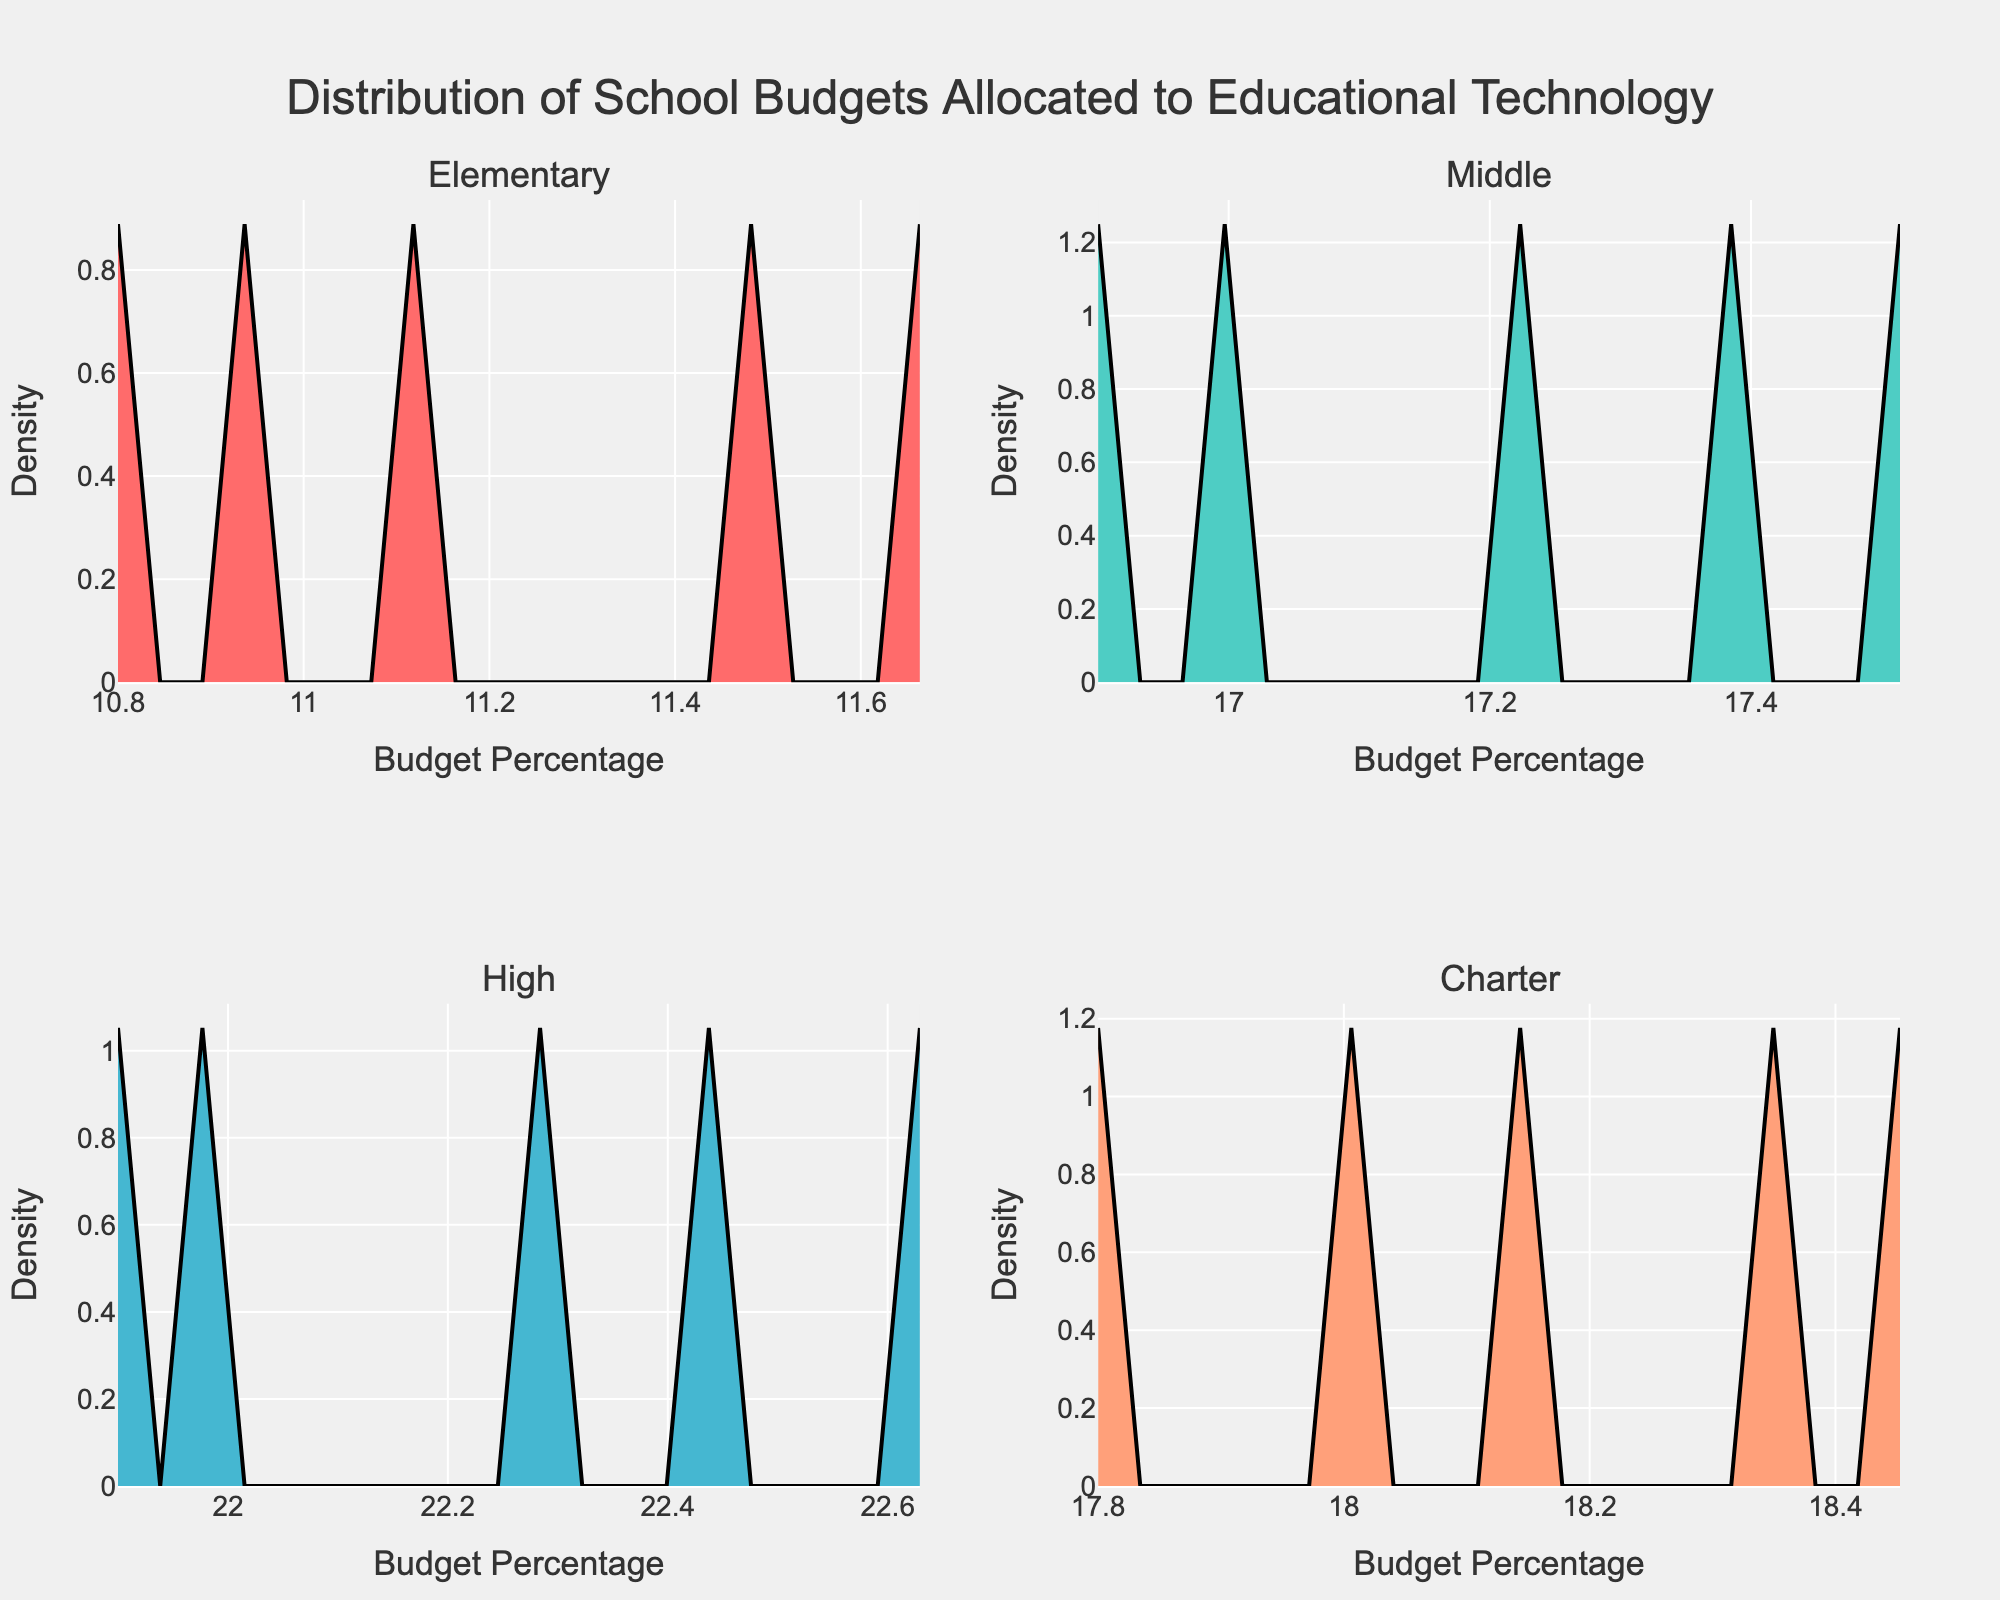What is the title of the figure? The title of the figure is located at the top and reads "Distribution of School Budgets Allocated to Educational Technology".
Answer: Distribution of School Budgets Allocated to Educational Technology Which school type appears in the top left subplot? The subplot titles indicate that "Elementary" is the school type in the top left subplot.
Answer: Elementary What is the x-axis label for the Charter subplot in the bottom right? The x-axis label for the Charter subplot at the bottom right is "Budget Percentage".
Answer: Budget Percentage Which school type has the highest peak in their density plot? The visual inspection of the peaks in the subplots shows that the High school subplot has the highest density peak.
Answer: High How many different school types are represented in the entire figure? Counting the subplot titles, there are four different school types represented: Elementary, Middle, High, and Charter.
Answer: Four Between Middle and Charter schools, which has a broader distribution of school budgets allocated to educational technology? By comparing the width of the density plots for Middle and Charter schools, it is clear that Middle schools have a somewhat broader distribution.
Answer: Middle Which subplot indicates that most schools have a budget percentage around 25%? The High school subplot shows most schools with a budget percentage around 25%, as indicated by the density peak near 25%.
Answer: High Is the density plot for Elementary schools skewed to the left or right? The Elementary school density plot has a longer tail on the right side, indicating it is skewed to the right.
Answer: Skewed to the right For which school type is the majority of their budget percentages between 18% and 20%? The Charter school density plot is highest between 18% and 20%, indicating most budget percentages fall within this range.
Answer: Charter Comparing Elementary and High schools, which has a more concentrated distribution of school budgets? The High school density plot is more peaked and less spread out compared to the Elementary plot, indicating a more concentrated distribution.
Answer: High 